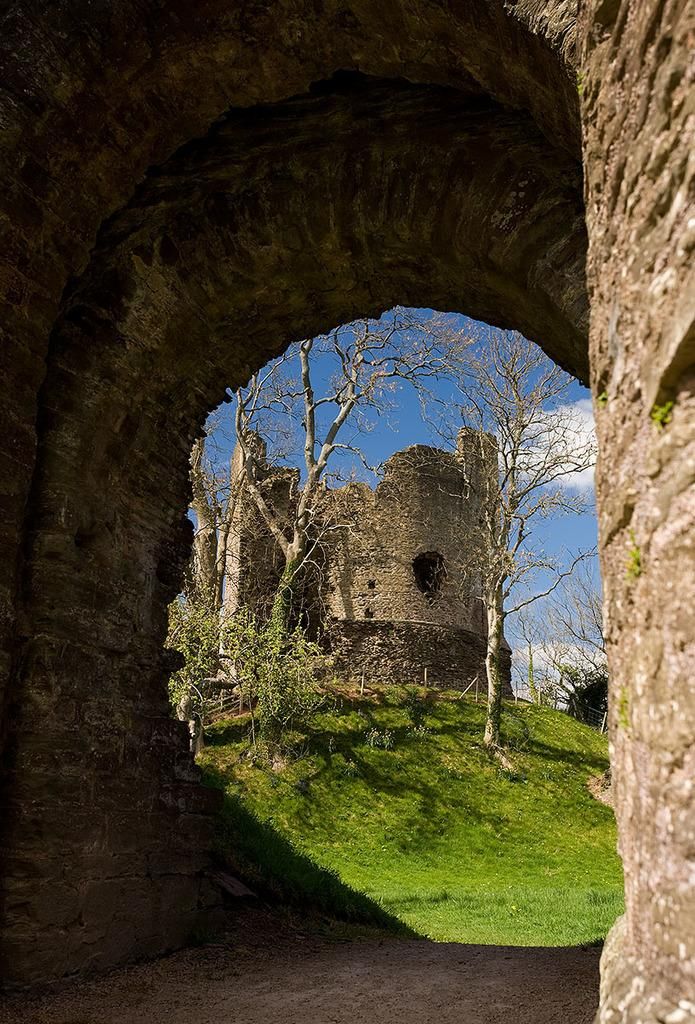What type of vegetation can be seen in the image? There are trees in the image. What structure is present in the image? There is a wall in the image. What can be seen in the background of the image? The sky is visible in the background of the image. How does the hope for a better future manifest itself in the image? There is no direct reference to hope or a better future in the image, as it primarily features trees and a wall. Can you describe the ear of the person in the image? There is no person present in the image, and therefore no ear can be observed. 